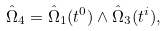<formula> <loc_0><loc_0><loc_500><loc_500>\hat { \Omega } _ { 4 } = \hat { \Omega } _ { 1 } ( t ^ { 0 } ) \wedge \hat { \Omega } _ { 3 } ( t ^ { i } ) ,</formula> 